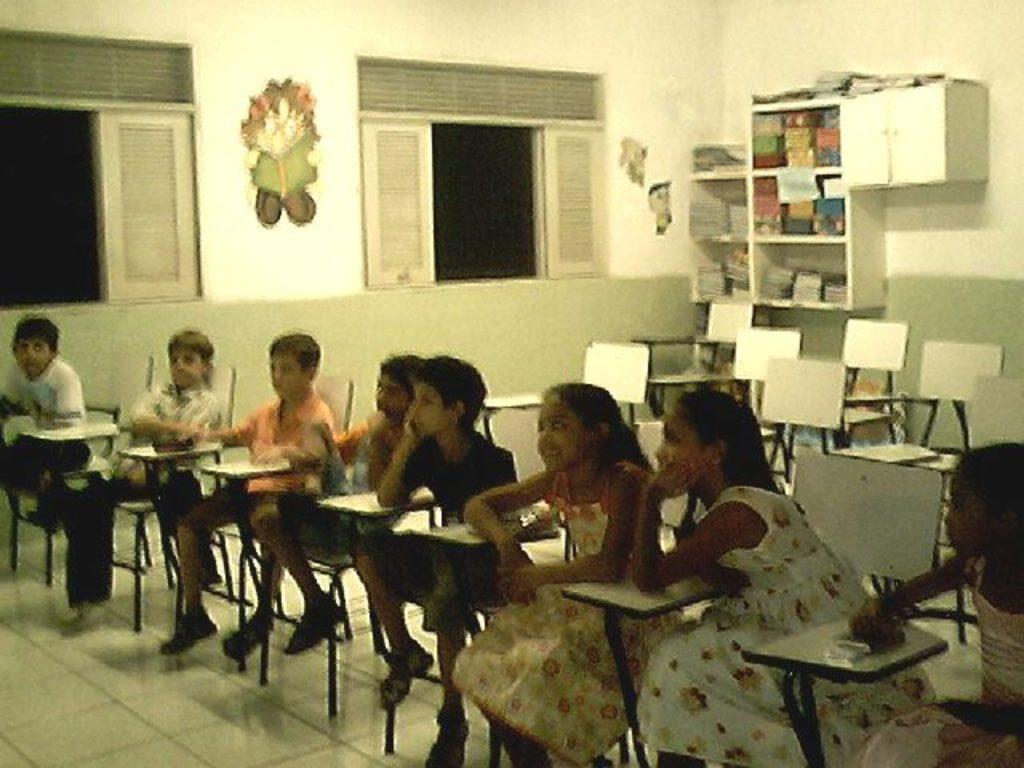What are the children in the image doing? The children are sitting on chairs in the image. What can be seen in the background of the image? There is a window, a sticker on the wall, the wall itself, a bookshelf, and empty chairs in the background. How many pizzas are on the table in the image? There is no table or pizzas present in the image. 